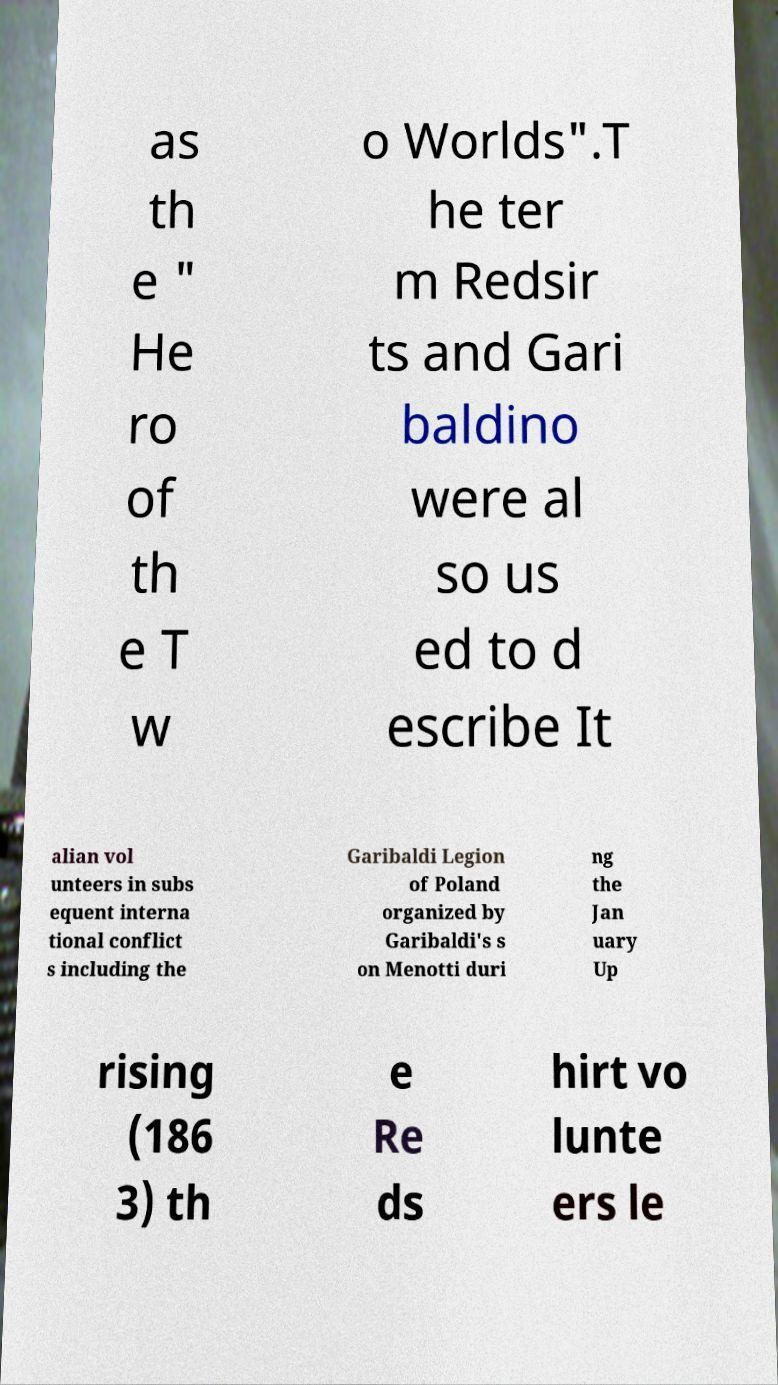Please read and relay the text visible in this image. What does it say? as th e " He ro of th e T w o Worlds".T he ter m Redsir ts and Gari baldino were al so us ed to d escribe It alian vol unteers in subs equent interna tional conflict s including the Garibaldi Legion of Poland organized by Garibaldi's s on Menotti duri ng the Jan uary Up rising (186 3) th e Re ds hirt vo lunte ers le 